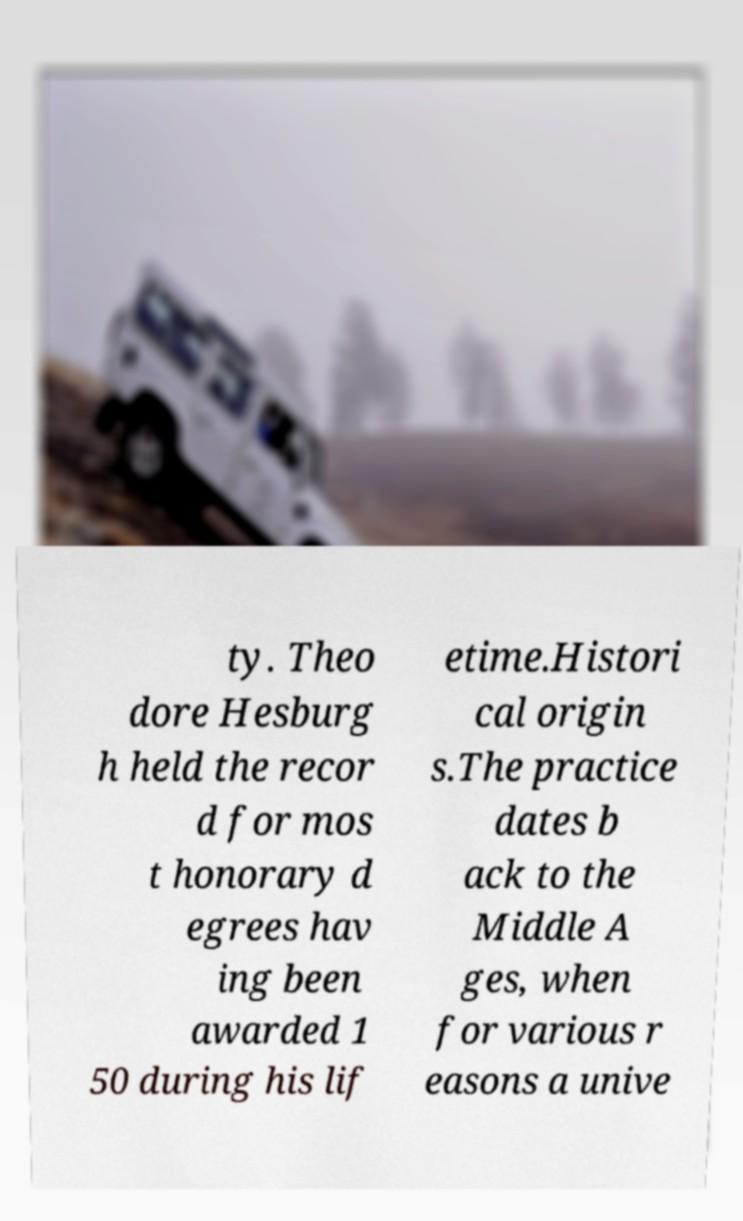Can you accurately transcribe the text from the provided image for me? ty. Theo dore Hesburg h held the recor d for mos t honorary d egrees hav ing been awarded 1 50 during his lif etime.Histori cal origin s.The practice dates b ack to the Middle A ges, when for various r easons a unive 